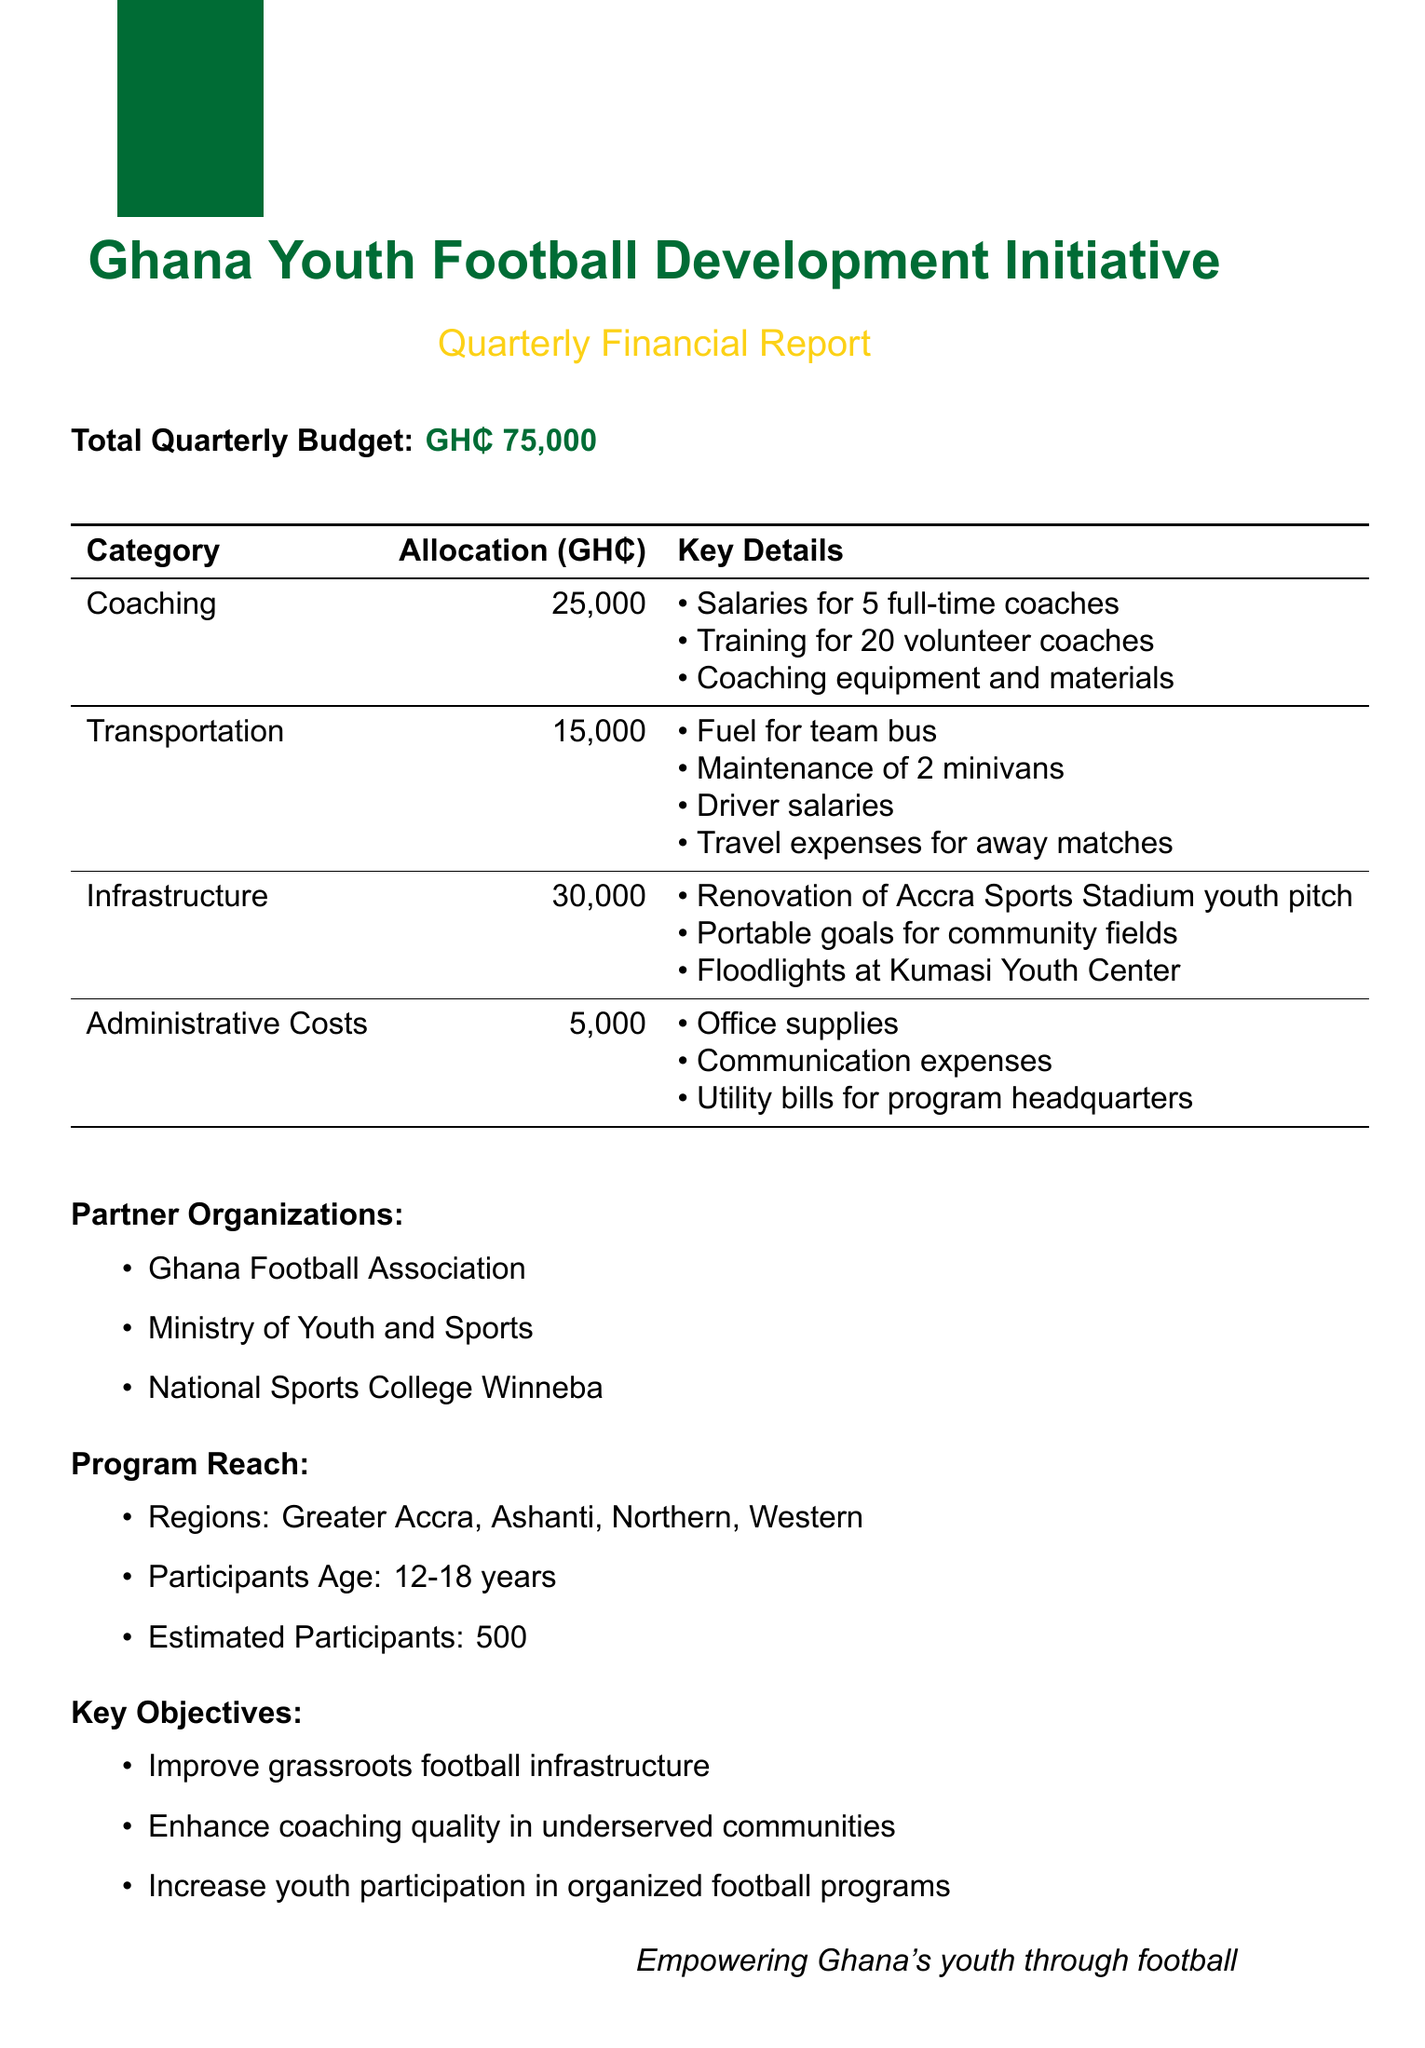What is the total quarterly budget? The total quarterly budget mentioned in the document is $75000.
Answer: GH₵ 75,000 How much is allocated for coaching? The budget breakdown shows that 25000 is allocated for coaching.
Answer: GH₵ 25,000 What is one of the key objectives of the program? The document lists key objectives including improving grassroots football infrastructure.
Answer: Improve grassroots football infrastructure How many participants are estimated for the program? The estimated participants for the program as stated in the document is 500.
Answer: 500 Which organization is mentioned as a partner? The document lists several partner organizations, including the Ghana Football Association.
Answer: Ghana Football Association How much funding is allocated for infrastructure? The budget breakdown specifies that 30000 is allocated for infrastructure.
Answer: GH₵ 30,000 What is included in the transportation budget? The transportation budget includes fuel for the team bus and travel expenses for away matches.
Answer: Fuel for team bus, travel expenses for away matches What age group does the program target? The document indicates that the program targets participants aged 12 to 18 years.
Answer: 12-18 years 